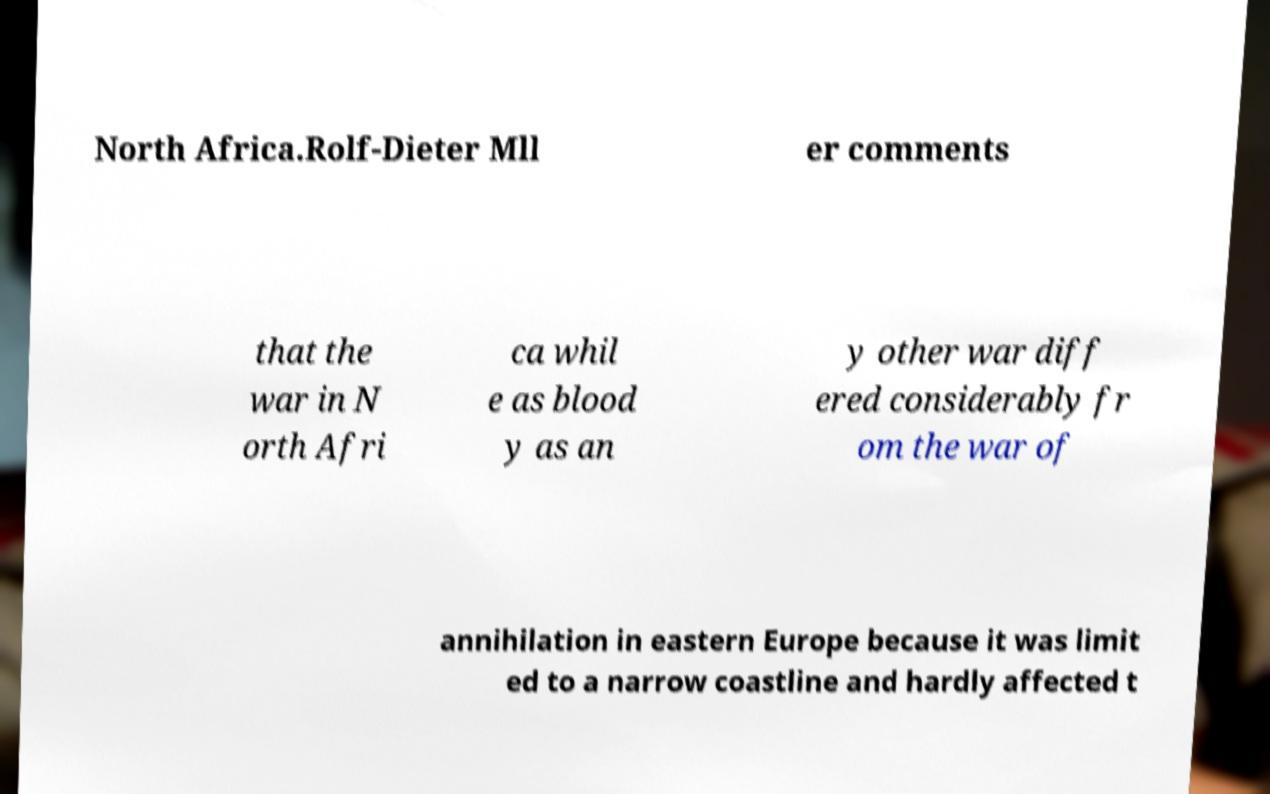Could you extract and type out the text from this image? North Africa.Rolf-Dieter Mll er comments that the war in N orth Afri ca whil e as blood y as an y other war diff ered considerably fr om the war of annihilation in eastern Europe because it was limit ed to a narrow coastline and hardly affected t 